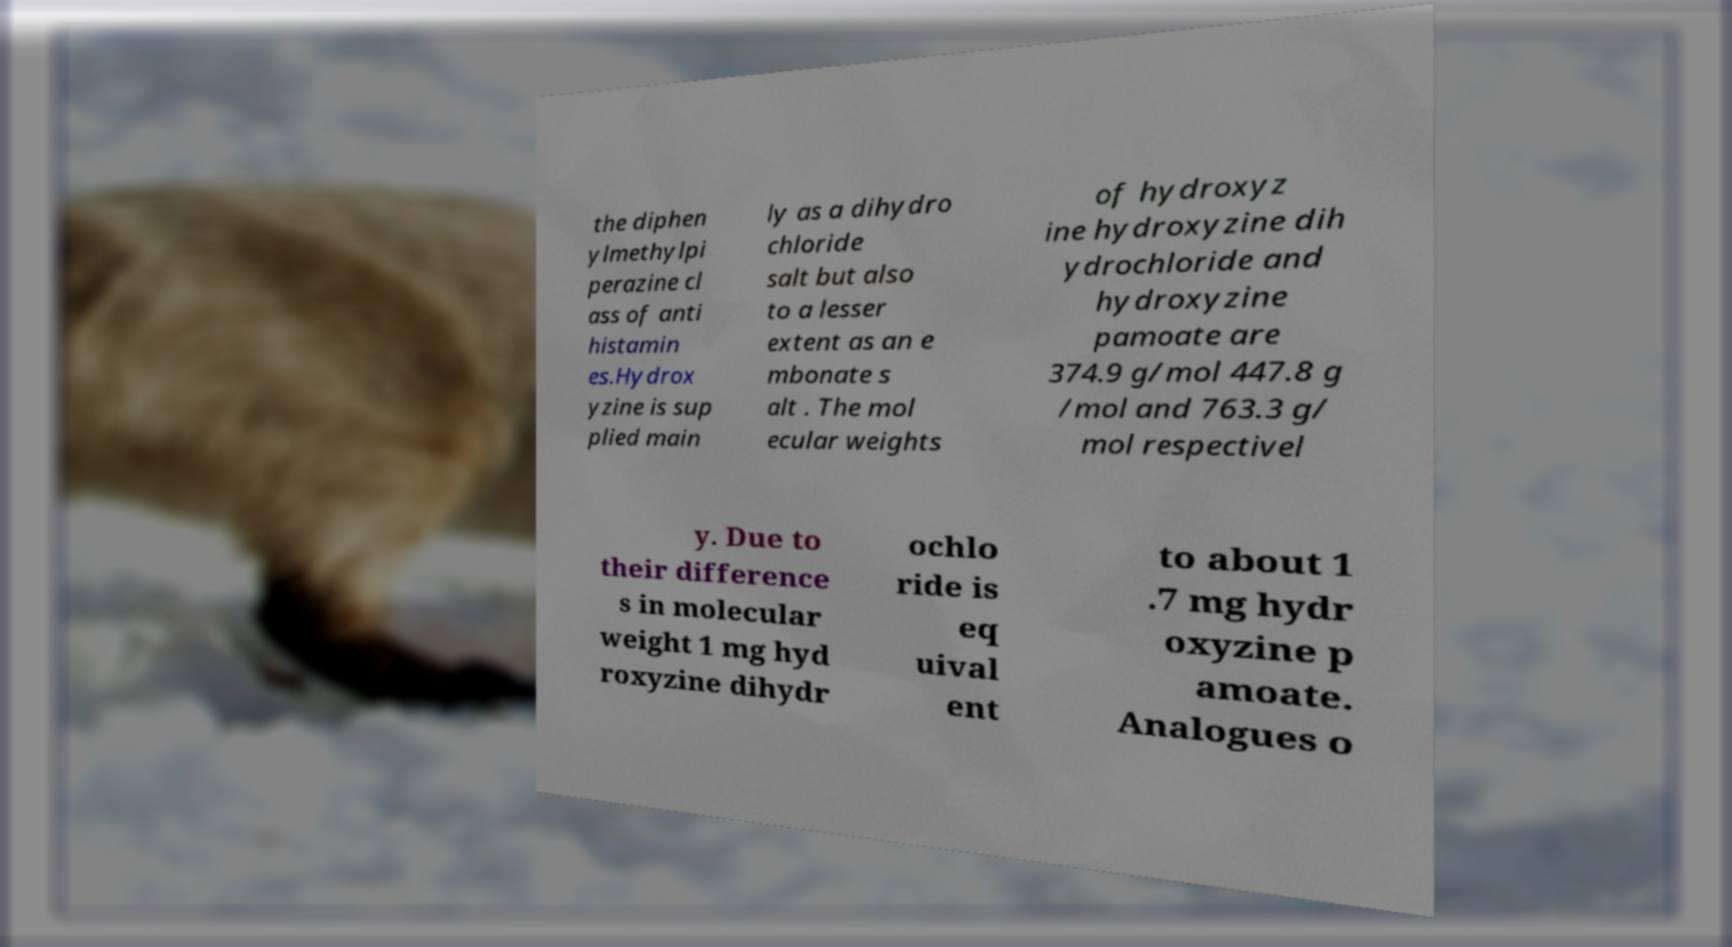Can you accurately transcribe the text from the provided image for me? the diphen ylmethylpi perazine cl ass of anti histamin es.Hydrox yzine is sup plied main ly as a dihydro chloride salt but also to a lesser extent as an e mbonate s alt . The mol ecular weights of hydroxyz ine hydroxyzine dih ydrochloride and hydroxyzine pamoate are 374.9 g/mol 447.8 g /mol and 763.3 g/ mol respectivel y. Due to their difference s in molecular weight 1 mg hyd roxyzine dihydr ochlo ride is eq uival ent to about 1 .7 mg hydr oxyzine p amoate. Analogues o 